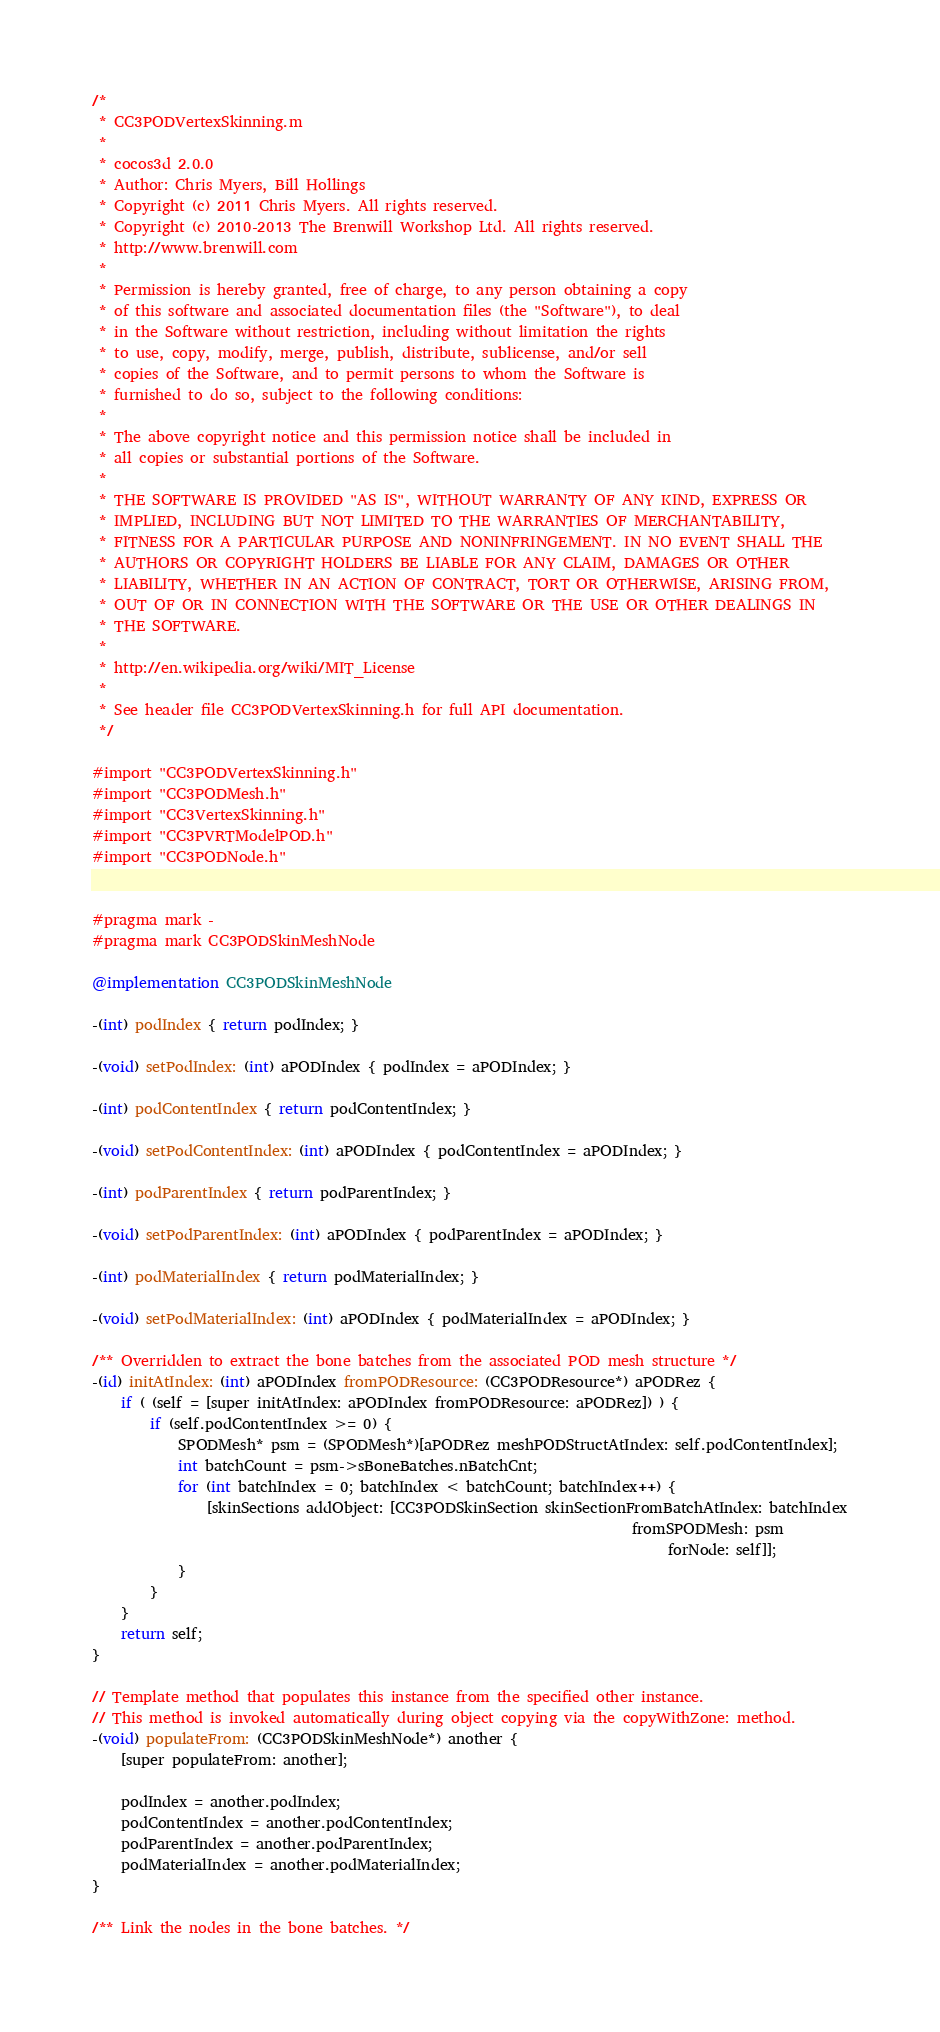<code> <loc_0><loc_0><loc_500><loc_500><_ObjectiveC_>/*
 * CC3PODVertexSkinning.m
 *
 * cocos3d 2.0.0
 * Author: Chris Myers, Bill Hollings
 * Copyright (c) 2011 Chris Myers. All rights reserved.
 * Copyright (c) 2010-2013 The Brenwill Workshop Ltd. All rights reserved.
 * http://www.brenwill.com
 *
 * Permission is hereby granted, free of charge, to any person obtaining a copy
 * of this software and associated documentation files (the "Software"), to deal
 * in the Software without restriction, including without limitation the rights
 * to use, copy, modify, merge, publish, distribute, sublicense, and/or sell
 * copies of the Software, and to permit persons to whom the Software is
 * furnished to do so, subject to the following conditions:
 * 
 * The above copyright notice and this permission notice shall be included in
 * all copies or substantial portions of the Software.
 * 
 * THE SOFTWARE IS PROVIDED "AS IS", WITHOUT WARRANTY OF ANY KIND, EXPRESS OR
 * IMPLIED, INCLUDING BUT NOT LIMITED TO THE WARRANTIES OF MERCHANTABILITY,
 * FITNESS FOR A PARTICULAR PURPOSE AND NONINFRINGEMENT. IN NO EVENT SHALL THE
 * AUTHORS OR COPYRIGHT HOLDERS BE LIABLE FOR ANY CLAIM, DAMAGES OR OTHER
 * LIABILITY, WHETHER IN AN ACTION OF CONTRACT, TORT OR OTHERWISE, ARISING FROM,
 * OUT OF OR IN CONNECTION WITH THE SOFTWARE OR THE USE OR OTHER DEALINGS IN
 * THE SOFTWARE.
 *
 * http://en.wikipedia.org/wiki/MIT_License
 * 
 * See header file CC3PODVertexSkinning.h for full API documentation.
 */

#import "CC3PODVertexSkinning.h"
#import "CC3PODMesh.h"
#import "CC3VertexSkinning.h"
#import "CC3PVRTModelPOD.h"
#import "CC3PODNode.h"


#pragma mark -
#pragma mark CC3PODSkinMeshNode

@implementation CC3PODSkinMeshNode

-(int) podIndex { return podIndex; }

-(void) setPodIndex: (int) aPODIndex { podIndex = aPODIndex; }

-(int) podContentIndex { return podContentIndex; }

-(void) setPodContentIndex: (int) aPODIndex { podContentIndex = aPODIndex; }

-(int) podParentIndex { return podParentIndex; }

-(void) setPodParentIndex: (int) aPODIndex { podParentIndex = aPODIndex; }

-(int) podMaterialIndex { return podMaterialIndex; }

-(void) setPodMaterialIndex: (int) aPODIndex { podMaterialIndex = aPODIndex; }

/** Overridden to extract the bone batches from the associated POD mesh structure */
-(id) initAtIndex: (int) aPODIndex fromPODResource: (CC3PODResource*) aPODRez {
	if ( (self = [super initAtIndex: aPODIndex fromPODResource: aPODRez]) ) {
		if (self.podContentIndex >= 0) {
			SPODMesh* psm = (SPODMesh*)[aPODRez meshPODStructAtIndex: self.podContentIndex];
			int batchCount = psm->sBoneBatches.nBatchCnt;
			for (int batchIndex = 0; batchIndex < batchCount; batchIndex++) {
				[skinSections addObject: [CC3PODSkinSection skinSectionFromBatchAtIndex: batchIndex
																		   fromSPODMesh: psm
																				forNode: self]];
			}
		}
	}
	return self; 
}

// Template method that populates this instance from the specified other instance.
// This method is invoked automatically during object copying via the copyWithZone: method.
-(void) populateFrom: (CC3PODSkinMeshNode*) another {
	[super populateFrom: another];
	
	podIndex = another.podIndex;
	podContentIndex = another.podContentIndex;
	podParentIndex = another.podParentIndex;
	podMaterialIndex = another.podMaterialIndex;
}

/** Link the nodes in the bone batches. */</code> 